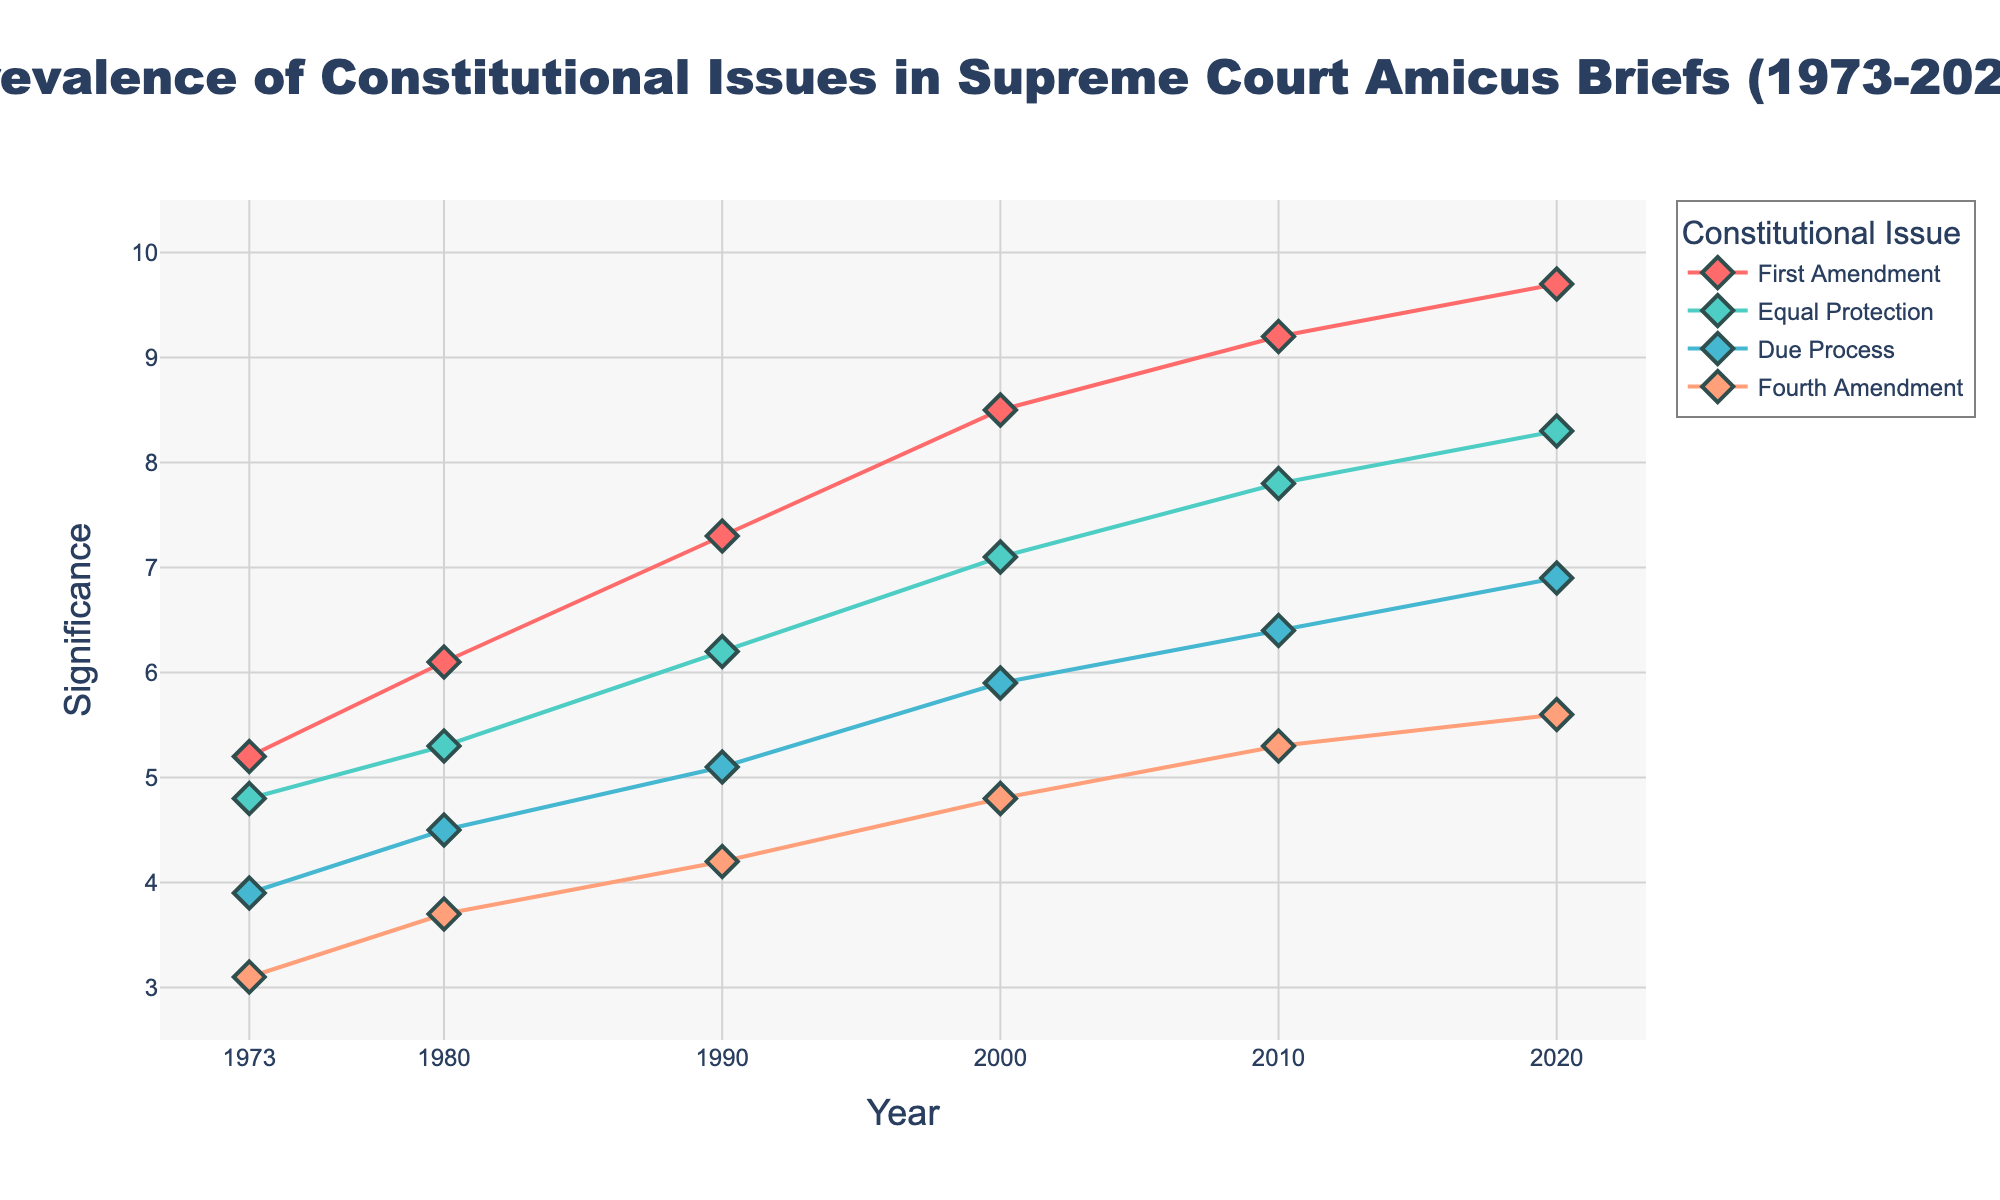What is the title of the figure? The title is usually found at the top of the figure. In this case, it provides a summary of what the plot represents.
Answer: Prevalence of Constitutional Issues in Supreme Court Amicus Briefs (1973-2020) Which constitutional issue had the highest significance in 2020? To answer this, look at the y-values for the points corresponding to the year 2020. The issue with the highest y-value will be the one with the highest significance.
Answer: First Amendment How many distinct constitutional issues are represented in the figure? To identify this, note the number of unique labels or traces in the legend of the plot.
Answer: Four What is the range of significance values on the y-axis? Examine the y-axis to find the minimum and maximum values indicated on the axis.
Answer: 2.5 to 10.5 Which year shows the highest significance value for the Fourth Amendment? Locate the line or points corresponding to the Fourth Amendment, and then find the year where this line reaches its highest y-value.
Answer: 2020 How did the significance of the First Amendment change from 1973 to 2020? Compare the y-values for the First Amendment in both years and describe the trend.
Answer: Increased What is the average significance of Due Process over the entire period? To find the average, sum up all significance values for Due Process and then divide by the number of data points. For Due Process (one value each for 1973, 1980, 1990, 2000, 2010, and 2020): (3.9 + 4.5 + 5.1 + 5.9 + 6.4 + 6.9) / 6 = 32.7 / 6 = 5.45
Answer: 5.45 Which two issues had the closest significance values in 1990? Observe the y-values for all issues in 1990 and identify the two issues whose y-values are nearest to each other.
Answer: Due Process and Fourth Amendment What is the difference in significance between Equal Protection and Fourth Amendment in 2000? Subtract the y-value for Fourth Amendment from the y-value for Equal Protection in 2000: 7.1 - 4.8 = 2.3
Answer: 2.3 Between 2010 and 2020, which constitutional issue saw the smallest change in significance? Calculate the absolute change for each issue between the years and identify the smallest change.
Answer: Fourth Amendment 